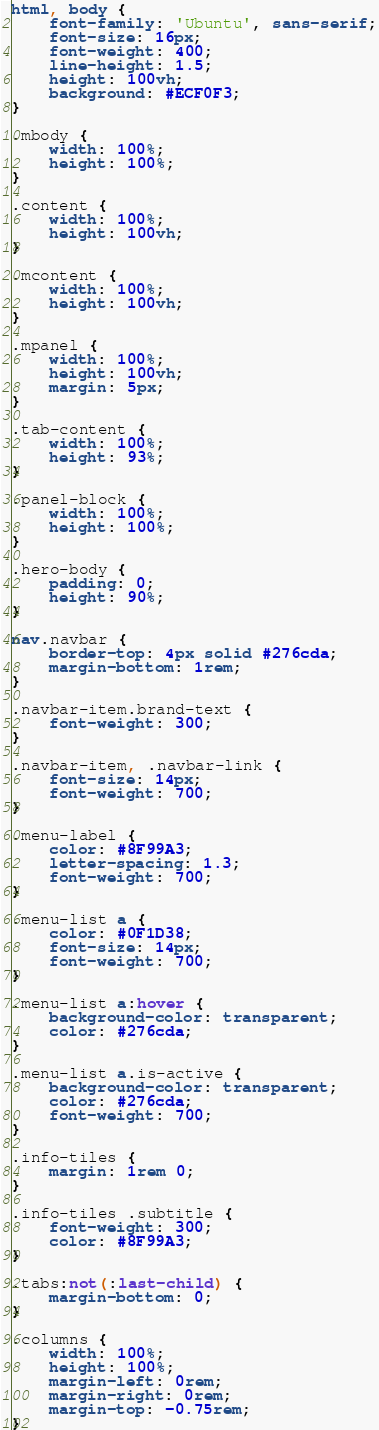<code> <loc_0><loc_0><loc_500><loc_500><_CSS_>
html, body {
    font-family: 'Ubuntu', sans-serif;
    font-size: 16px;
    font-weight: 400;
    line-height: 1.5;
    height: 100vh;
    background: #ECF0F3;
}

.mbody {
    width: 100%;
    height: 100%;
}

.content {
    width: 100%;
    height: 100vh;
}

.mcontent {
    width: 100%;
    height: 100vh;
}

.mpanel {
    width: 100%;
    height: 100vh;
    margin: 5px;
}

.tab-content {
    width: 100%;
    height: 93%;
}

.panel-block {
    width: 100%;
    height: 100%;
}

.hero-body {
    padding: 0;
    height: 90%;
}

nav.navbar {
    border-top: 4px solid #276cda;
    margin-bottom: 1rem;
}

.navbar-item.brand-text {
    font-weight: 300;
}

.navbar-item, .navbar-link {
    font-size: 14px;
    font-weight: 700;
}

.menu-label {
    color: #8F99A3;
    letter-spacing: 1.3;
    font-weight: 700;
}

.menu-list a {
    color: #0F1D38;
    font-size: 14px;
    font-weight: 700;
}

.menu-list a:hover {
    background-color: transparent;
    color: #276cda;
}

.menu-list a.is-active {
    background-color: transparent;
    color: #276cda;
    font-weight: 700;
}

.info-tiles {
    margin: 1rem 0;
}

.info-tiles .subtitle {
    font-weight: 300;
    color: #8F99A3;
}

.tabs:not(:last-child) {
    margin-bottom: 0;
}

.columns {
    width: 100%;
    height: 100%;
    margin-left: 0rem;
    margin-right: 0rem;
    margin-top: -0.75rem;
}
</code> 